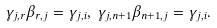<formula> <loc_0><loc_0><loc_500><loc_500>\gamma _ { j , r } \beta _ { r , j } = \gamma _ { j , i } , \, \gamma _ { j , n + 1 } \beta _ { n + 1 , j } = \gamma _ { j , i } .</formula> 